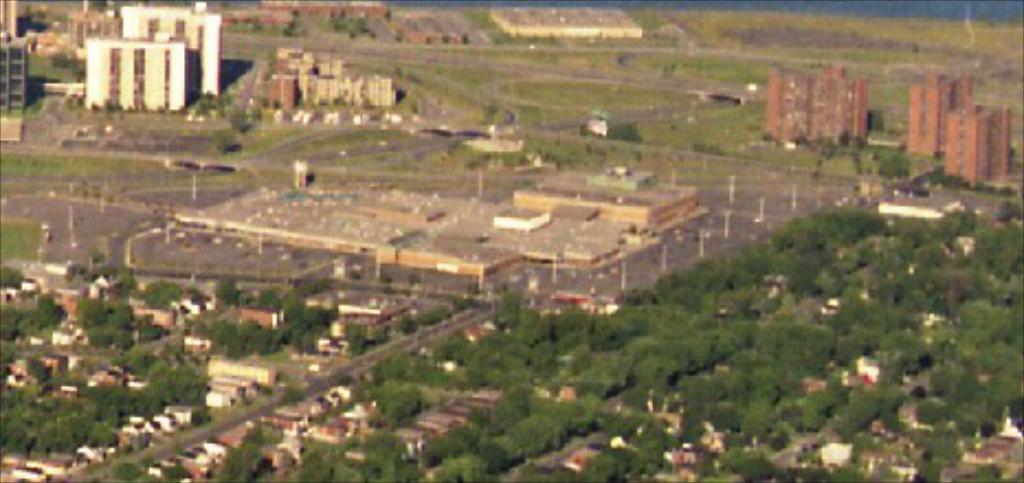What type of view is shown in the image? The image is an aerial view of a place. What structures can be seen in the image? There are buildings and houses in the image. What natural elements are visible in the image? There are trees visible in the image. Can you tell me how many kittens are playing in the trees in the image? There are no kittens present in the image; it only shows buildings, houses, and trees. 